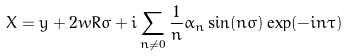<formula> <loc_0><loc_0><loc_500><loc_500>X = y + 2 w R \sigma + i \sum _ { n \not = 0 } \frac { 1 } { n } \alpha _ { n } \sin ( n \sigma ) \exp ( - i n \tau )</formula> 